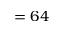<formula> <loc_0><loc_0><loc_500><loc_500>= 6 4</formula> 